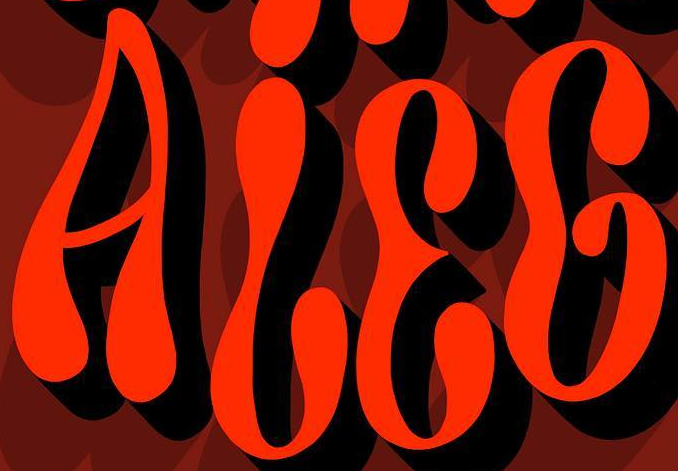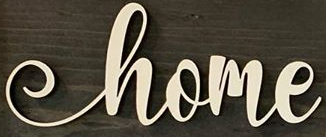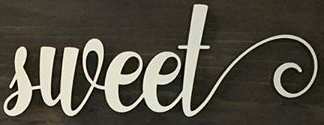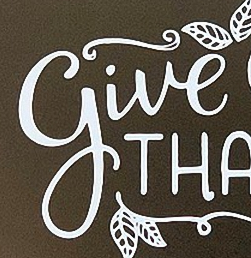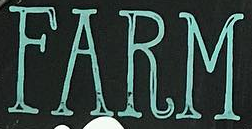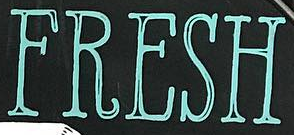Read the text content from these images in order, separated by a semicolon. ALEG; home; sweet; give; FARM; FRESH 